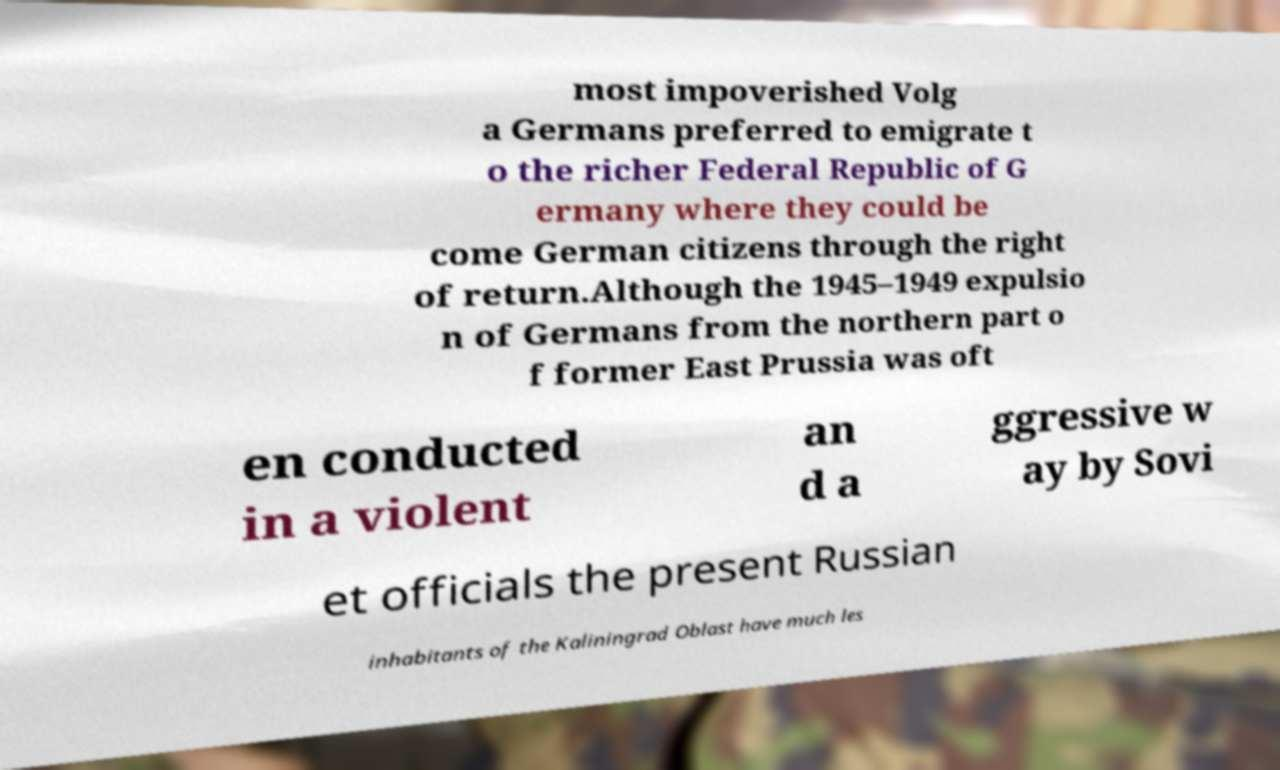What messages or text are displayed in this image? I need them in a readable, typed format. most impoverished Volg a Germans preferred to emigrate t o the richer Federal Republic of G ermany where they could be come German citizens through the right of return.Although the 1945–1949 expulsio n of Germans from the northern part o f former East Prussia was oft en conducted in a violent an d a ggressive w ay by Sovi et officials the present Russian inhabitants of the Kaliningrad Oblast have much les 